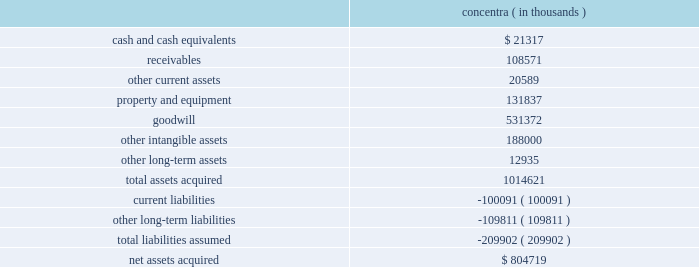Humana inc .
Notes to consolidated financial statements 2014 ( continued ) 3 .
Acquisitions on december 21 , 2010 , we acquired concentra inc. , or concentra , a health care company based in addison , texas , for cash consideration of $ 804.7 million .
Through its affiliated clinicians , concentra delivers occupational medicine , urgent care , physical therapy , and wellness services to workers and the general public through its operation of medical centers and worksite medical facilities .
The concentra acquisition provides entry into the primary care space on a national scale , offering additional means for achieving health and wellness solutions and providing an expandable platform for growth with a management team experienced in physician asset management and alternate site care .
The preliminary fair values of concentra 2019s assets acquired and liabilities assumed at the date of the acquisition are summarized as follows : concentra ( in thousands ) .
The other intangible assets , which primarily consist of customer relationships and trade name , have a weighted average useful life of 13.7 years .
Approximately $ 57.9 million of the acquired goodwill is deductible for tax purposes .
The purchase price allocation is preliminary , subject to completion of valuation analyses , including , for example , refining assumptions used to calculate the fair value of other intangible assets .
The purchase agreement contains provisions under which there may be future consideration paid or received related to the subsequent determination of working capital that existed at the acquisition date .
Any payments or receipts for provisional amounts for working capital will be recorded as an adjustment to goodwill when paid or received .
The results of operations and financial condition of concentra have been included in our consolidated statements of income and consolidated balance sheets from the acquisition date .
In connection with the acquisition , we recognized approximately $ 14.9 million of acquisition-related costs , primarily banker and other professional fees , in selling , general and administrative expense .
The proforma financial information assuming the acquisition had occurred as of january 1 , 2009 was not material to our results of operations .
On october 31 , 2008 , we acquired php companies , inc .
( d/b/a cariten healthcare ) , or cariten , for cash consideration of approximately $ 291.0 million , including the payment of $ 34.9 million during 2010 to settle a purchase price contingency .
The cariten acquisition increased our commercial fully-insured and aso presence as well as our medicare hmo presence in eastern tennessee .
During 2009 , we continued our review of the fair value estimate of certain other intangible and net tangible assets acquired .
This review resulted in a decrease of $ 27.1 million in the fair value of other intangible assets , primarily related to the fair value assigned to the customer contracts acquired .
There was a corresponding adjustment to goodwill and deferred income taxes .
The .
What are the total current assets for concentra? 
Computations: ((21317 + 108571) / 20589)
Answer: 6.30861. 